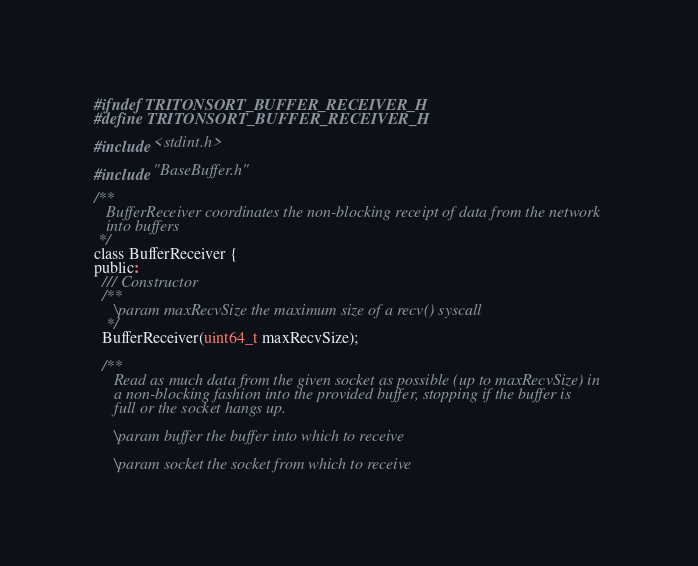<code> <loc_0><loc_0><loc_500><loc_500><_C_>#ifndef TRITONSORT_BUFFER_RECEIVER_H
#define TRITONSORT_BUFFER_RECEIVER_H

#include <stdint.h>

#include "BaseBuffer.h"

/**
   BufferReceiver coordinates the non-blocking receipt of data from the network
   into buffers
 */
class BufferReceiver {
public:
  /// Constructor
  /**
     \param maxRecvSize the maximum size of a recv() syscall
   */
  BufferReceiver(uint64_t maxRecvSize);

  /**
     Read as much data from the given socket as possible (up to maxRecvSize) in
     a non-blocking fashion into the provided buffer, stopping if the buffer is
     full or the socket hangs up.

     \param buffer the buffer into which to receive

     \param socket the socket from which to receive
</code> 